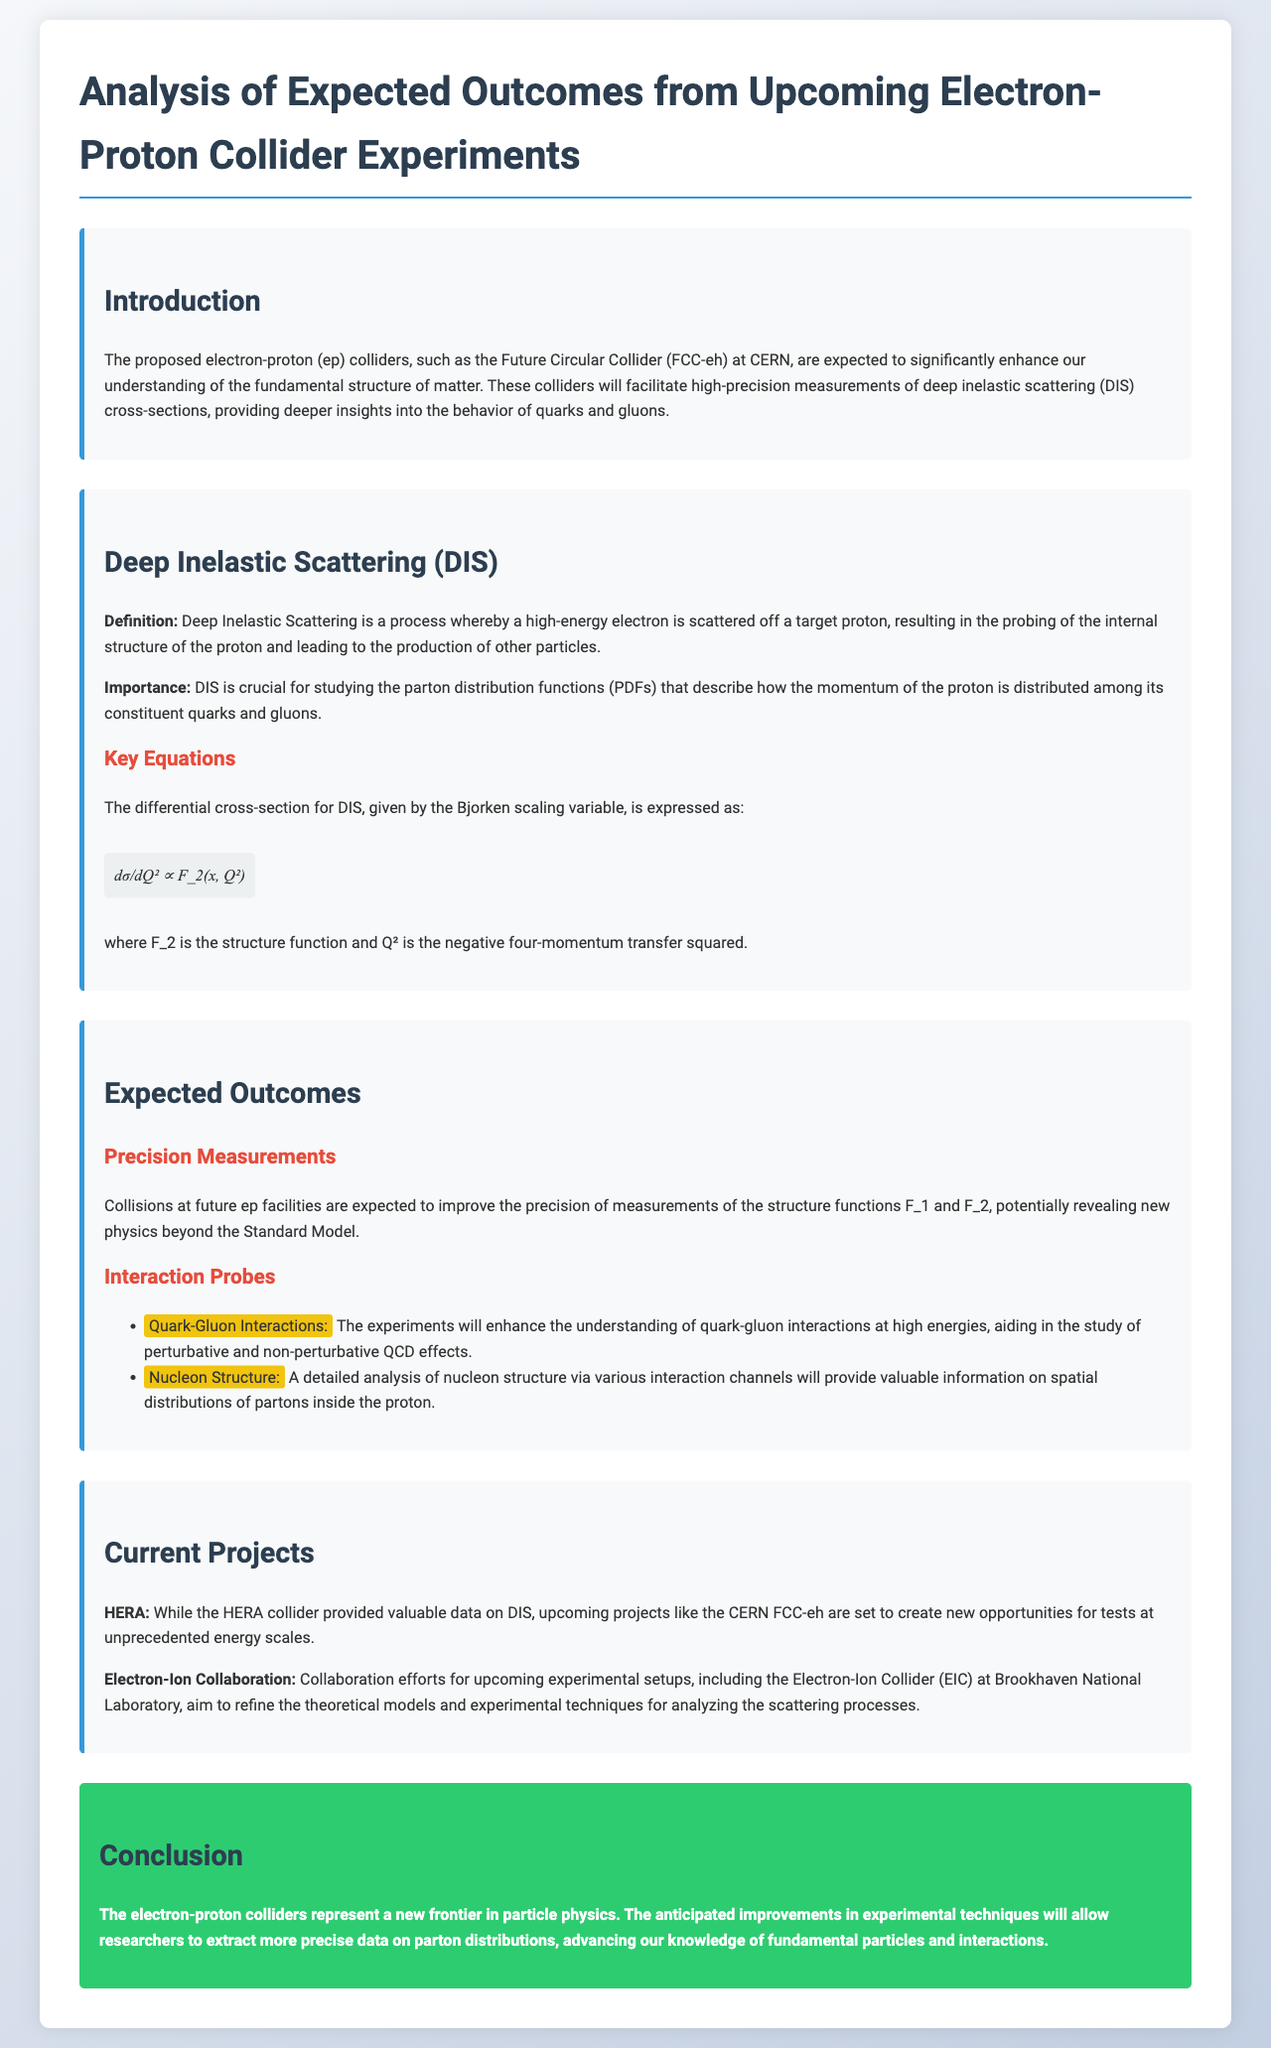What is the proposed electron-proton collider at CERN? The document mentions the Future Circular Collider (FCC-eh) as the proposed electron-proton collider at CERN.
Answer: Future Circular Collider (FCC-eh) What process does Deep Inelastic Scattering involve? The document defines Deep Inelastic Scattering as a process whereby a high-energy electron is scattered off a target proton.
Answer: Scattering of a high-energy electron off a target proton What is the main purpose of Deep Inelastic Scattering? The importance section states that DIS is crucial for studying the parton distribution functions that describe momentum distribution among quarks and gluons.
Answer: Studying parton distribution functions What two structure functions are expected to be measured with high precision? The section on expected outcomes mentions structure functions F_1 and F_2 are expected to be measured with high precision.
Answer: F_1 and F_2 What is the relationship between the differential cross-section for DIS and the Bjorken scaling variable? The key equation in the document expresses the differential cross-section for DIS in terms of F_2 and Q², relating them through the equation dσ/dQ² ∝ F_2(x, Q²).
Answer: dσ/dQ² ∝ F_2(x, Q²) What existing facility has contributed valuable data on DIS? The document refers to HERA as an existing facility that has provided valuable data on DIS.
Answer: HERA Which collaboration is mentioned for upcoming experimental setups? The document mentions the Electron-Ion Collaboration for upcoming experimental setups.
Answer: Electron-Ion Collaboration What is the significance of upcoming electron-proton colliders? The conclusion highlights that they represent a new frontier in particle physics and enhance knowledge on fundamental particles and interactions.
Answer: A new frontier in particle physics What are two areas of interaction probes mentioned in the document? The section on expected outcomes lists Quark-Gluon Interactions and Nucleon Structure as areas of interaction probes.
Answer: Quark-Gluon Interactions and Nucleon Structure 